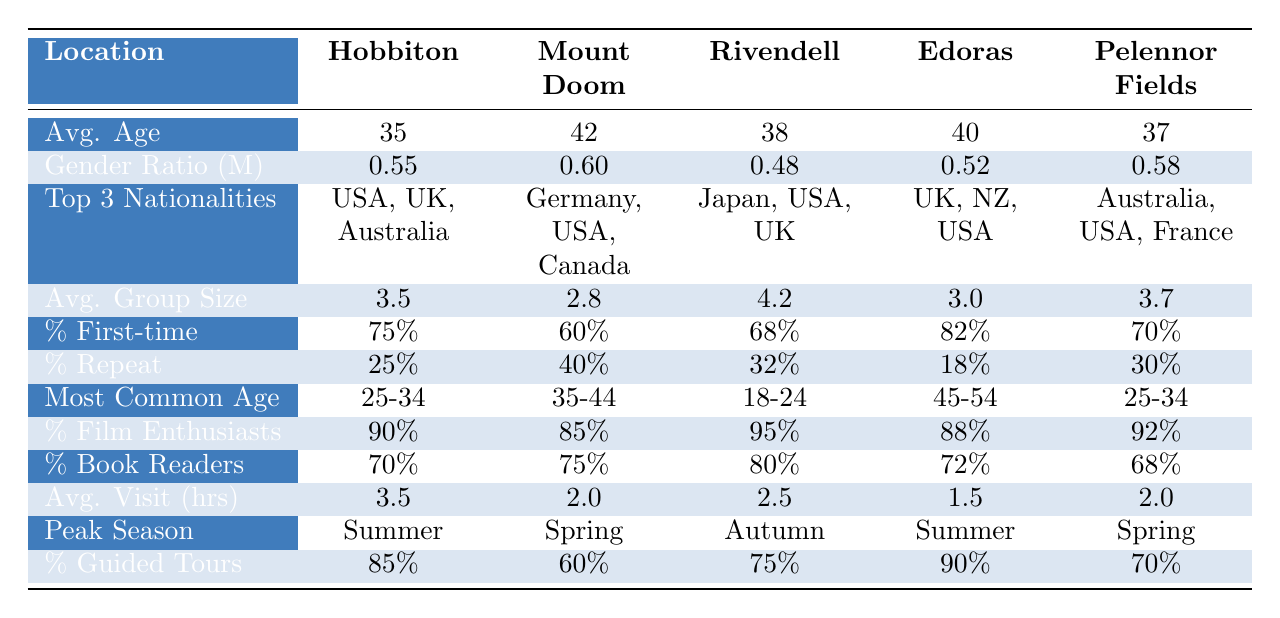What is the average age of visitors at Rivendell? The table shows the average age for each location. For Rivendell, the average age is listed as 38.
Answer: 38 Which location has the highest percentage of first-time visitors? Looking at the percentage of first-time visitors for each location, Edoras has the highest percentage at 82%.
Answer: Edoras What is the gender ratio (male) at Hobbiton? The table specifies a gender ratio for Hobbiton, which is 0.55.
Answer: 0.55 How many visitors belong to the most common age group at Pelennor Fields? For Pelennor Fields, the most common age group is listed as 25-34. To determine the count, we refer to demographics and estimates, but the table only identifies the age group, not specific numbers.
Answer: 25-34 (age group) Which nationality is common among visitors at the Edoras filming location? The top three nationalities for visitors at Edoras are listed as UK, New Zealand, and USA.
Answer: UK, New Zealand, USA Is the average visit duration at Rivendell longer than that at Edoras? The average visit duration at Rivendell is 2.5 hours, while at Edoras it is 1.5 hours. Since 2.5 is greater than 1.5, the average visit duration at Rivendell is indeed longer.
Answer: Yes What is the average group size at Mount Doom? The average group size for Mount Doom is given in the table as 2.8.
Answer: 2.8 Calculate the difference in film enthusiast percentage between Hobbiton and Mount Doom. The percentage for Hobbiton is 90%, and for Mount Doom, it is 85%. The difference is calculated as 90 - 85 = 5.
Answer: 5% Are more visitors generally film enthusiasts at Rivendell or Pelennor Fields? The table shows that Rivendell has 95% film enthusiasts, while Pelennor Fields has 92%. Since 95% is greater than 92%, more visitors at Rivendell are film enthusiasts.
Answer: Rivendell Which filming location has the lowest percentage of repeat visitors? Examining the table, Edoras has the lowest percentage of repeat visitors at 18%.
Answer: Edoras What is the peak season for visitors at Hobbiton? The table indicates that the peak season for Hobbiton is Summer.
Answer: Summer 